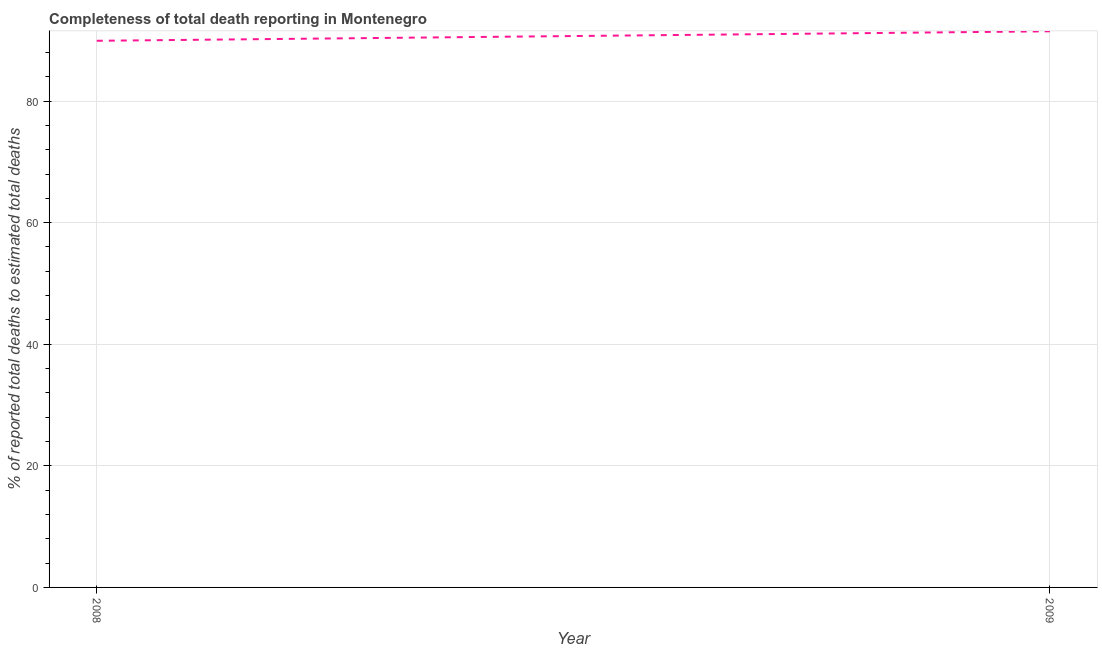What is the completeness of total death reports in 2009?
Your response must be concise. 91.48. Across all years, what is the maximum completeness of total death reports?
Ensure brevity in your answer.  91.48. Across all years, what is the minimum completeness of total death reports?
Your answer should be compact. 89.92. In which year was the completeness of total death reports maximum?
Your response must be concise. 2009. What is the sum of the completeness of total death reports?
Ensure brevity in your answer.  181.4. What is the difference between the completeness of total death reports in 2008 and 2009?
Provide a short and direct response. -1.56. What is the average completeness of total death reports per year?
Give a very brief answer. 90.7. What is the median completeness of total death reports?
Offer a very short reply. 90.7. In how many years, is the completeness of total death reports greater than 32 %?
Provide a succinct answer. 2. Do a majority of the years between 2009 and 2008 (inclusive) have completeness of total death reports greater than 60 %?
Provide a short and direct response. No. What is the ratio of the completeness of total death reports in 2008 to that in 2009?
Provide a short and direct response. 0.98. Is the completeness of total death reports in 2008 less than that in 2009?
Your answer should be very brief. Yes. Does the completeness of total death reports monotonically increase over the years?
Provide a short and direct response. Yes. How many years are there in the graph?
Keep it short and to the point. 2. Does the graph contain any zero values?
Give a very brief answer. No. Does the graph contain grids?
Give a very brief answer. Yes. What is the title of the graph?
Offer a terse response. Completeness of total death reporting in Montenegro. What is the label or title of the X-axis?
Keep it short and to the point. Year. What is the label or title of the Y-axis?
Make the answer very short. % of reported total deaths to estimated total deaths. What is the % of reported total deaths to estimated total deaths of 2008?
Make the answer very short. 89.92. What is the % of reported total deaths to estimated total deaths in 2009?
Your response must be concise. 91.48. What is the difference between the % of reported total deaths to estimated total deaths in 2008 and 2009?
Give a very brief answer. -1.56. What is the ratio of the % of reported total deaths to estimated total deaths in 2008 to that in 2009?
Make the answer very short. 0.98. 